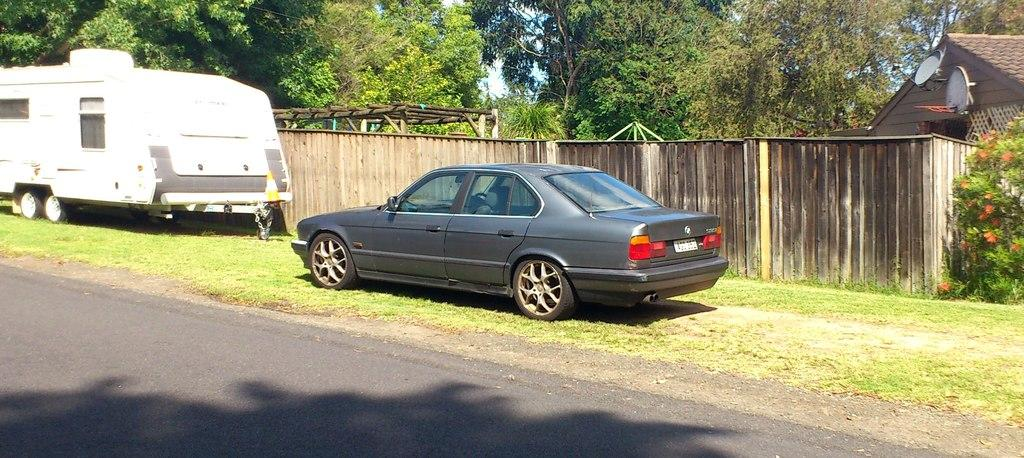What is at the bottom of the image? There is a road at the bottom of the image. What type of vehicles can be seen in the image? Electric vehicles are present in the image. What structure is visible in the image? There is a wall in the image. What type of plant is visible in the image? A plant is visible in the image. What type of flowers are present in the image? Flowers are present in the image. What type of vegetation is visible in the image? Grass is visible in the image. What type of building is present in the image? There is a house in the image. What type of objects made of wood are present in the image? Wooden objects are present in the image. What can be seen in the background of the image? There are trees and the sky visible in the background of the image. Can you tell me how many thumbs are visible in the image? There are no thumbs visible in the image. What type of appliance is being used by the person talking in the image? There is no person talking in the image, and therefore no appliance can be associated with them. 